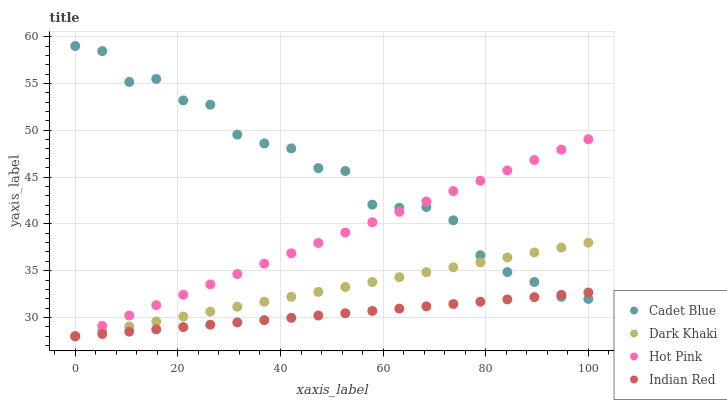Does Indian Red have the minimum area under the curve?
Answer yes or no. Yes. Does Cadet Blue have the maximum area under the curve?
Answer yes or no. Yes. Does Cadet Blue have the minimum area under the curve?
Answer yes or no. No. Does Indian Red have the maximum area under the curve?
Answer yes or no. No. Is Dark Khaki the smoothest?
Answer yes or no. Yes. Is Cadet Blue the roughest?
Answer yes or no. Yes. Is Indian Red the smoothest?
Answer yes or no. No. Is Indian Red the roughest?
Answer yes or no. No. Does Dark Khaki have the lowest value?
Answer yes or no. Yes. Does Cadet Blue have the lowest value?
Answer yes or no. No. Does Cadet Blue have the highest value?
Answer yes or no. Yes. Does Indian Red have the highest value?
Answer yes or no. No. Does Dark Khaki intersect Hot Pink?
Answer yes or no. Yes. Is Dark Khaki less than Hot Pink?
Answer yes or no. No. Is Dark Khaki greater than Hot Pink?
Answer yes or no. No. 